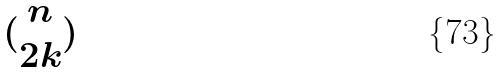<formula> <loc_0><loc_0><loc_500><loc_500>( \begin{matrix} n \\ 2 k \end{matrix} )</formula> 